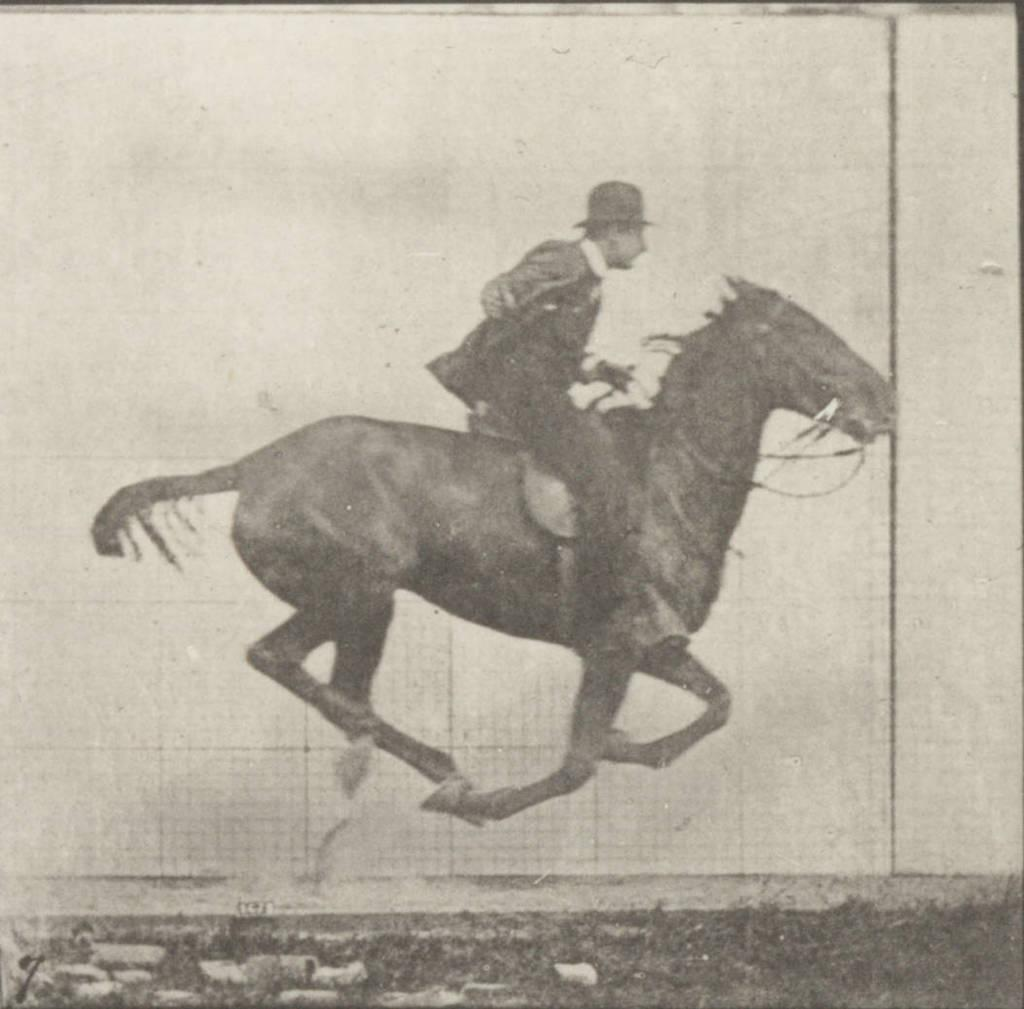What is depicted in the image? There is a picture of a man in the image. What is the man doing in the picture? The man is riding a horse in the picture. What type of jeans is the man wearing in the image? The image does not show the man's clothing, so it cannot be determined if he is wearing jeans or any other type of clothing. 